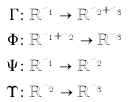Convert formula to latex. <formula><loc_0><loc_0><loc_500><loc_500>\Gamma & \colon \mathbb { R } ^ { n _ { 1 } } \to \mathbb { R } ^ { n _ { 2 } + n _ { 3 } } \\ \Phi & \colon \mathbb { R } ^ { n _ { 1 } + n _ { 2 } } \to \mathbb { R } ^ { n _ { 3 } } \\ \Psi & \colon \mathbb { R } ^ { n _ { 1 } } \to \mathbb { R } ^ { n _ { 2 } } \\ \Upsilon & \colon \mathbb { R } ^ { n _ { 2 } } \to \mathbb { R } ^ { n _ { 3 } }</formula> 